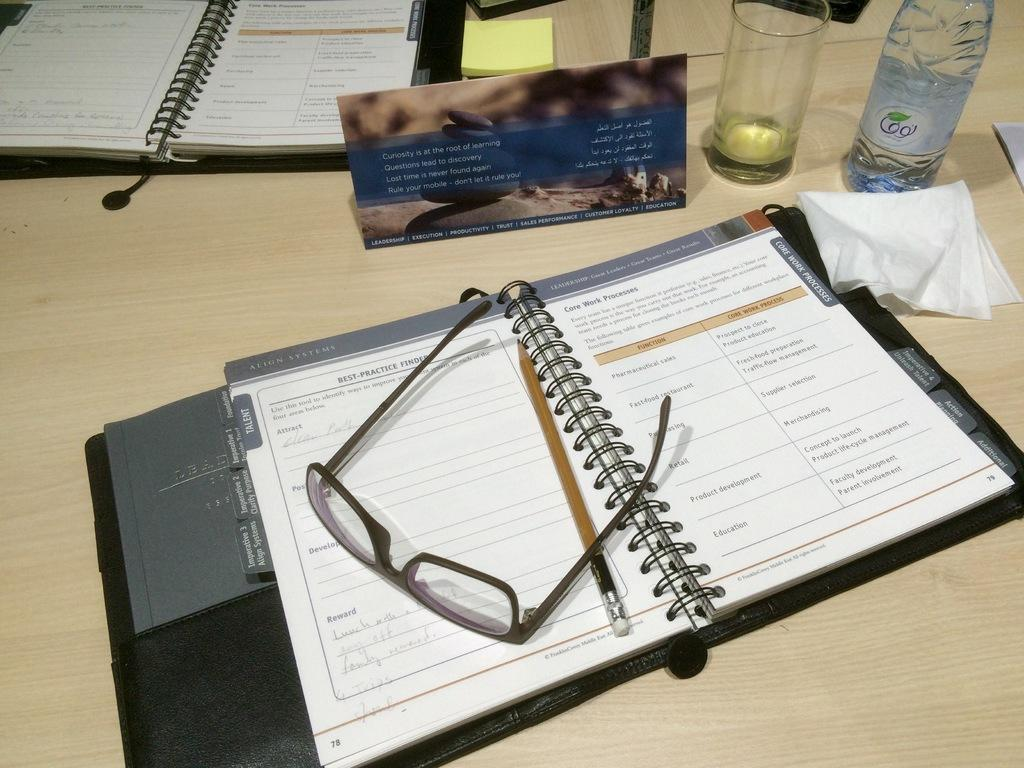How many diaries are visible in the image? There are two diaries in the image. What other items can be seen in the image? There are spectacles, a water bottle, a tissue, and a glass visible in the image. What is on top of the table in the image? There is a name board on top of the table in the image. What type of yam is being used as a spoon in the image? There is no yam or spoon present in the image. Is there a sheet visible in the image? No, there is no sheet visible in the image. 